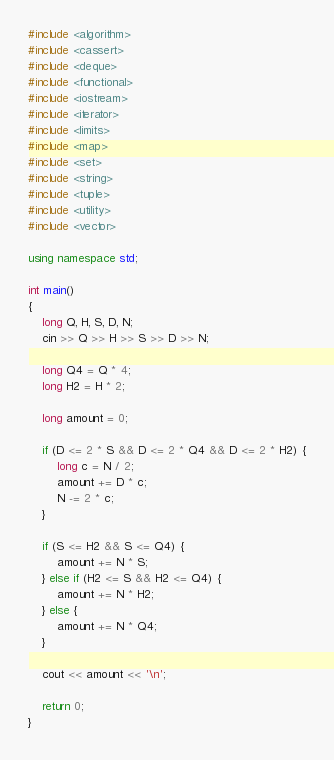<code> <loc_0><loc_0><loc_500><loc_500><_C++_>#include <algorithm>
#include <cassert>
#include <deque>
#include <functional>
#include <iostream>
#include <iterator>
#include <limits>
#include <map>
#include <set>
#include <string>
#include <tuple>
#include <utility>
#include <vector>

using namespace std;

int main()
{
    long Q, H, S, D, N;
    cin >> Q >> H >> S >> D >> N;

    long Q4 = Q * 4;
    long H2 = H * 2;

    long amount = 0;

    if (D <= 2 * S && D <= 2 * Q4 && D <= 2 * H2) {
        long c = N / 2;
        amount += D * c;
        N -= 2 * c;
    }

    if (S <= H2 && S <= Q4) {
        amount += N * S;
    } else if (H2 <= S && H2 <= Q4) {
        amount += N * H2;
    } else {
        amount += N * Q4;
    }

    cout << amount << '\n';

    return 0;
}
</code> 